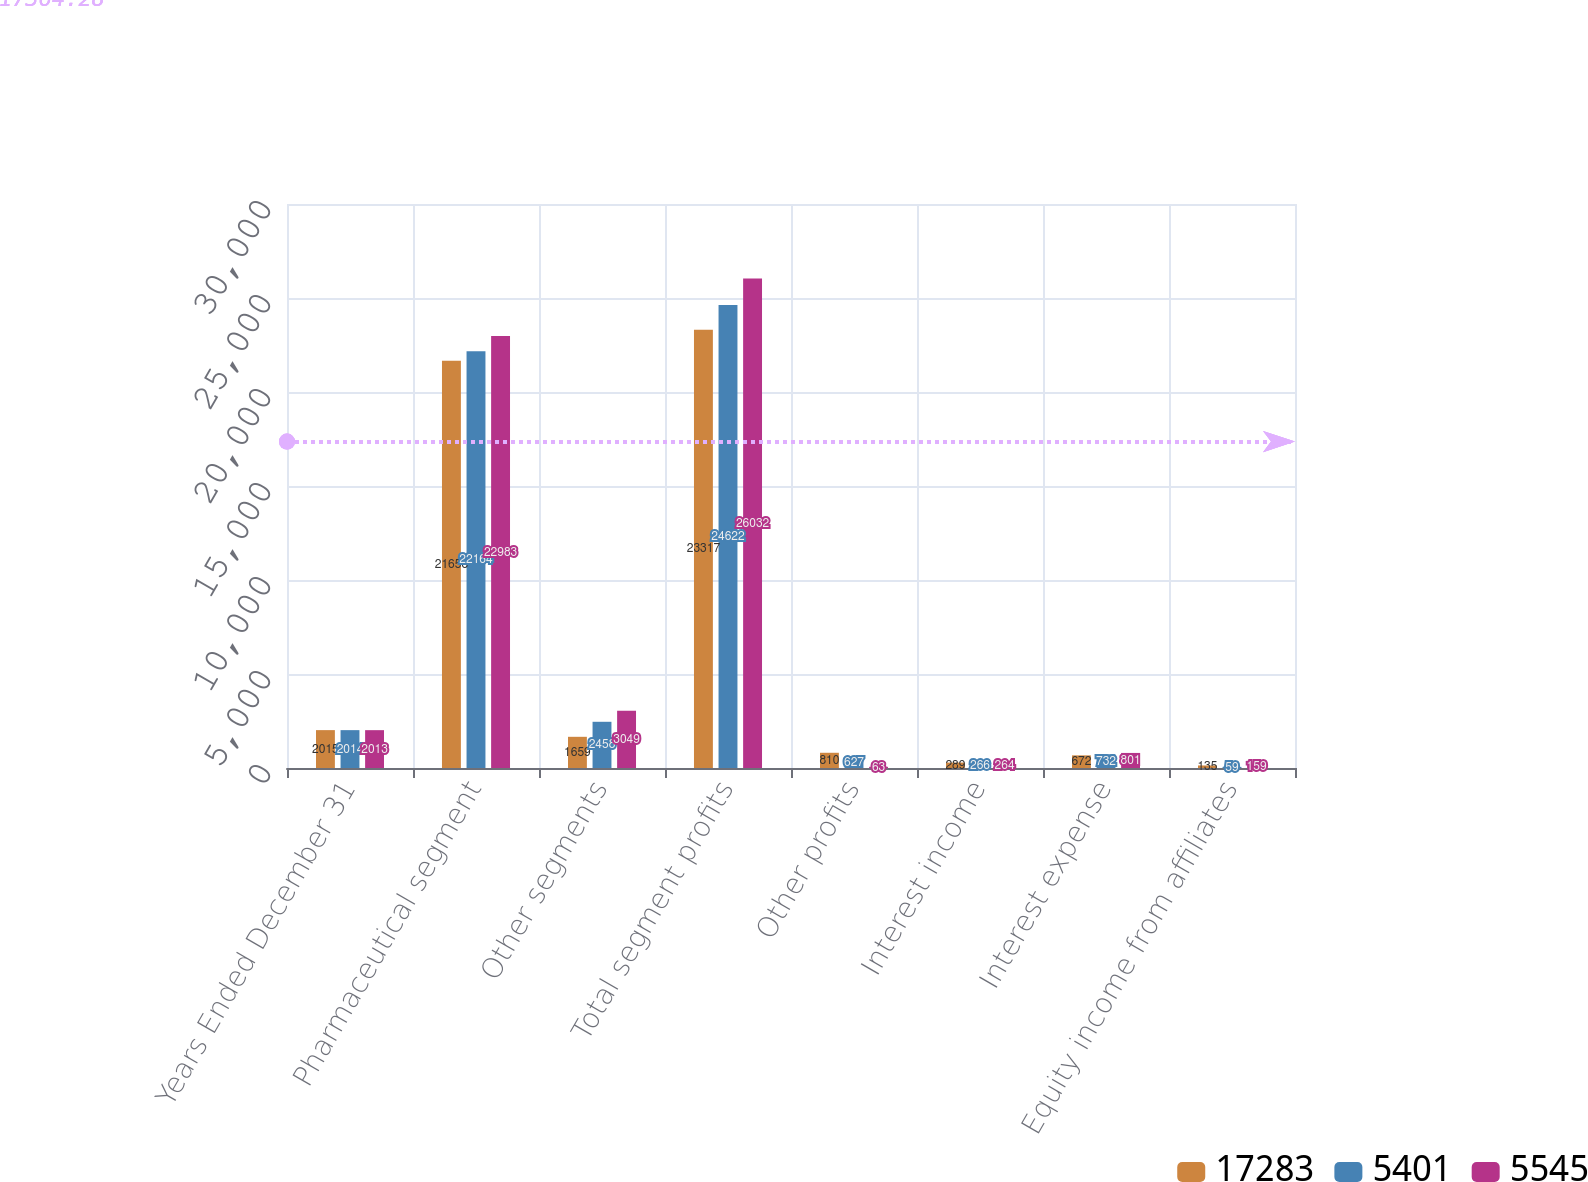<chart> <loc_0><loc_0><loc_500><loc_500><stacked_bar_chart><ecel><fcel>Years Ended December 31<fcel>Pharmaceutical segment<fcel>Other segments<fcel>Total segment profits<fcel>Other profits<fcel>Interest income<fcel>Interest expense<fcel>Equity income from affiliates<nl><fcel>17283<fcel>2015<fcel>21658<fcel>1659<fcel>23317<fcel>810<fcel>289<fcel>672<fcel>135<nl><fcel>5401<fcel>2014<fcel>22164<fcel>2458<fcel>24622<fcel>627<fcel>266<fcel>732<fcel>59<nl><fcel>5545<fcel>2013<fcel>22983<fcel>3049<fcel>26032<fcel>63<fcel>264<fcel>801<fcel>159<nl></chart> 